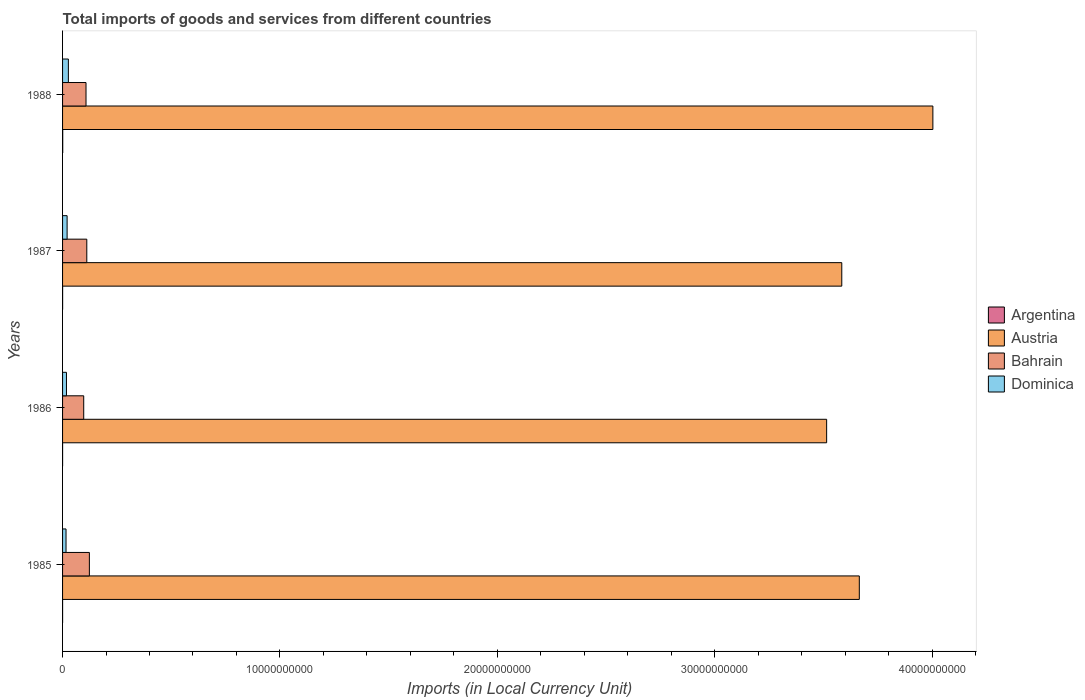How many different coloured bars are there?
Provide a short and direct response. 4. How many groups of bars are there?
Your response must be concise. 4. What is the Amount of goods and services imports in Dominica in 1985?
Ensure brevity in your answer.  1.60e+08. Across all years, what is the maximum Amount of goods and services imports in Dominica?
Offer a very short reply. 2.67e+08. Across all years, what is the minimum Amount of goods and services imports in Bahrain?
Your answer should be compact. 9.73e+08. In which year was the Amount of goods and services imports in Dominica maximum?
Give a very brief answer. 1988. What is the total Amount of goods and services imports in Bahrain in the graph?
Your response must be concise. 4.40e+09. What is the difference between the Amount of goods and services imports in Bahrain in 1986 and that in 1987?
Offer a terse response. -1.41e+08. What is the difference between the Amount of goods and services imports in Austria in 1988 and the Amount of goods and services imports in Argentina in 1985?
Make the answer very short. 4.00e+1. What is the average Amount of goods and services imports in Argentina per year?
Your answer should be very brief. 2.41e+06. In the year 1988, what is the difference between the Amount of goods and services imports in Argentina and Amount of goods and services imports in Austria?
Your response must be concise. -4.00e+1. In how many years, is the Amount of goods and services imports in Austria greater than 10000000000 LCU?
Your response must be concise. 4. What is the ratio of the Amount of goods and services imports in Argentina in 1986 to that in 1987?
Provide a short and direct response. 0.36. What is the difference between the highest and the second highest Amount of goods and services imports in Austria?
Make the answer very short. 3.38e+09. What is the difference between the highest and the lowest Amount of goods and services imports in Austria?
Your answer should be compact. 4.89e+09. In how many years, is the Amount of goods and services imports in Dominica greater than the average Amount of goods and services imports in Dominica taken over all years?
Make the answer very short. 2. Is it the case that in every year, the sum of the Amount of goods and services imports in Bahrain and Amount of goods and services imports in Argentina is greater than the sum of Amount of goods and services imports in Dominica and Amount of goods and services imports in Austria?
Give a very brief answer. No. What does the 1st bar from the top in 1985 represents?
Provide a short and direct response. Dominica. What does the 4th bar from the bottom in 1987 represents?
Make the answer very short. Dominica. What is the difference between two consecutive major ticks on the X-axis?
Provide a short and direct response. 1.00e+1. Are the values on the major ticks of X-axis written in scientific E-notation?
Give a very brief answer. No. Does the graph contain any zero values?
Your answer should be very brief. No. Does the graph contain grids?
Give a very brief answer. No. Where does the legend appear in the graph?
Your response must be concise. Center right. How many legend labels are there?
Your answer should be very brief. 4. What is the title of the graph?
Your answer should be very brief. Total imports of goods and services from different countries. What is the label or title of the X-axis?
Make the answer very short. Imports (in Local Currency Unit). What is the label or title of the Y-axis?
Your answer should be very brief. Years. What is the Imports (in Local Currency Unit) in Argentina in 1985?
Offer a very short reply. 3.33e+05. What is the Imports (in Local Currency Unit) in Austria in 1985?
Keep it short and to the point. 3.67e+1. What is the Imports (in Local Currency Unit) in Bahrain in 1985?
Provide a short and direct response. 1.23e+09. What is the Imports (in Local Currency Unit) of Dominica in 1985?
Your answer should be compact. 1.60e+08. What is the Imports (in Local Currency Unit) of Argentina in 1986?
Your response must be concise. 6.31e+05. What is the Imports (in Local Currency Unit) in Austria in 1986?
Give a very brief answer. 3.52e+1. What is the Imports (in Local Currency Unit) in Bahrain in 1986?
Your response must be concise. 9.73e+08. What is the Imports (in Local Currency Unit) of Dominica in 1986?
Provide a short and direct response. 1.79e+08. What is the Imports (in Local Currency Unit) of Argentina in 1987?
Provide a succinct answer. 1.77e+06. What is the Imports (in Local Currency Unit) in Austria in 1987?
Make the answer very short. 3.58e+1. What is the Imports (in Local Currency Unit) in Bahrain in 1987?
Your answer should be very brief. 1.11e+09. What is the Imports (in Local Currency Unit) in Dominica in 1987?
Your response must be concise. 2.09e+08. What is the Imports (in Local Currency Unit) in Argentina in 1988?
Provide a short and direct response. 6.90e+06. What is the Imports (in Local Currency Unit) in Austria in 1988?
Provide a succinct answer. 4.00e+1. What is the Imports (in Local Currency Unit) in Bahrain in 1988?
Provide a succinct answer. 1.08e+09. What is the Imports (in Local Currency Unit) of Dominica in 1988?
Your answer should be very brief. 2.67e+08. Across all years, what is the maximum Imports (in Local Currency Unit) of Argentina?
Your answer should be compact. 6.90e+06. Across all years, what is the maximum Imports (in Local Currency Unit) of Austria?
Your response must be concise. 4.00e+1. Across all years, what is the maximum Imports (in Local Currency Unit) of Bahrain?
Your answer should be very brief. 1.23e+09. Across all years, what is the maximum Imports (in Local Currency Unit) in Dominica?
Give a very brief answer. 2.67e+08. Across all years, what is the minimum Imports (in Local Currency Unit) of Argentina?
Make the answer very short. 3.33e+05. Across all years, what is the minimum Imports (in Local Currency Unit) in Austria?
Your answer should be compact. 3.52e+1. Across all years, what is the minimum Imports (in Local Currency Unit) of Bahrain?
Ensure brevity in your answer.  9.73e+08. Across all years, what is the minimum Imports (in Local Currency Unit) of Dominica?
Ensure brevity in your answer.  1.60e+08. What is the total Imports (in Local Currency Unit) in Argentina in the graph?
Keep it short and to the point. 9.63e+06. What is the total Imports (in Local Currency Unit) in Austria in the graph?
Your answer should be very brief. 1.48e+11. What is the total Imports (in Local Currency Unit) of Bahrain in the graph?
Provide a short and direct response. 4.40e+09. What is the total Imports (in Local Currency Unit) of Dominica in the graph?
Make the answer very short. 8.15e+08. What is the difference between the Imports (in Local Currency Unit) of Argentina in 1985 and that in 1986?
Give a very brief answer. -2.99e+05. What is the difference between the Imports (in Local Currency Unit) of Austria in 1985 and that in 1986?
Provide a short and direct response. 1.50e+09. What is the difference between the Imports (in Local Currency Unit) of Bahrain in 1985 and that in 1986?
Your response must be concise. 2.60e+08. What is the difference between the Imports (in Local Currency Unit) of Dominica in 1985 and that in 1986?
Your answer should be compact. -1.96e+07. What is the difference between the Imports (in Local Currency Unit) in Argentina in 1985 and that in 1987?
Offer a very short reply. -1.43e+06. What is the difference between the Imports (in Local Currency Unit) of Austria in 1985 and that in 1987?
Provide a short and direct response. 8.06e+08. What is the difference between the Imports (in Local Currency Unit) of Bahrain in 1985 and that in 1987?
Give a very brief answer. 1.19e+08. What is the difference between the Imports (in Local Currency Unit) in Dominica in 1985 and that in 1987?
Give a very brief answer. -4.97e+07. What is the difference between the Imports (in Local Currency Unit) of Argentina in 1985 and that in 1988?
Provide a succinct answer. -6.57e+06. What is the difference between the Imports (in Local Currency Unit) in Austria in 1985 and that in 1988?
Provide a short and direct response. -3.38e+09. What is the difference between the Imports (in Local Currency Unit) of Bahrain in 1985 and that in 1988?
Offer a very short reply. 1.55e+08. What is the difference between the Imports (in Local Currency Unit) in Dominica in 1985 and that in 1988?
Provide a succinct answer. -1.07e+08. What is the difference between the Imports (in Local Currency Unit) of Argentina in 1986 and that in 1987?
Provide a succinct answer. -1.14e+06. What is the difference between the Imports (in Local Currency Unit) of Austria in 1986 and that in 1987?
Your answer should be compact. -6.96e+08. What is the difference between the Imports (in Local Currency Unit) in Bahrain in 1986 and that in 1987?
Offer a very short reply. -1.41e+08. What is the difference between the Imports (in Local Currency Unit) of Dominica in 1986 and that in 1987?
Offer a very short reply. -3.01e+07. What is the difference between the Imports (in Local Currency Unit) in Argentina in 1986 and that in 1988?
Your answer should be compact. -6.27e+06. What is the difference between the Imports (in Local Currency Unit) of Austria in 1986 and that in 1988?
Your answer should be very brief. -4.89e+09. What is the difference between the Imports (in Local Currency Unit) in Bahrain in 1986 and that in 1988?
Your answer should be very brief. -1.05e+08. What is the difference between the Imports (in Local Currency Unit) in Dominica in 1986 and that in 1988?
Offer a terse response. -8.78e+07. What is the difference between the Imports (in Local Currency Unit) of Argentina in 1987 and that in 1988?
Keep it short and to the point. -5.13e+06. What is the difference between the Imports (in Local Currency Unit) in Austria in 1987 and that in 1988?
Keep it short and to the point. -4.19e+09. What is the difference between the Imports (in Local Currency Unit) in Bahrain in 1987 and that in 1988?
Provide a short and direct response. 3.59e+07. What is the difference between the Imports (in Local Currency Unit) in Dominica in 1987 and that in 1988?
Your response must be concise. -5.78e+07. What is the difference between the Imports (in Local Currency Unit) in Argentina in 1985 and the Imports (in Local Currency Unit) in Austria in 1986?
Your response must be concise. -3.52e+1. What is the difference between the Imports (in Local Currency Unit) in Argentina in 1985 and the Imports (in Local Currency Unit) in Bahrain in 1986?
Your answer should be very brief. -9.73e+08. What is the difference between the Imports (in Local Currency Unit) of Argentina in 1985 and the Imports (in Local Currency Unit) of Dominica in 1986?
Provide a succinct answer. -1.79e+08. What is the difference between the Imports (in Local Currency Unit) of Austria in 1985 and the Imports (in Local Currency Unit) of Bahrain in 1986?
Make the answer very short. 3.57e+1. What is the difference between the Imports (in Local Currency Unit) in Austria in 1985 and the Imports (in Local Currency Unit) in Dominica in 1986?
Provide a short and direct response. 3.65e+1. What is the difference between the Imports (in Local Currency Unit) in Bahrain in 1985 and the Imports (in Local Currency Unit) in Dominica in 1986?
Your answer should be very brief. 1.05e+09. What is the difference between the Imports (in Local Currency Unit) in Argentina in 1985 and the Imports (in Local Currency Unit) in Austria in 1987?
Offer a terse response. -3.58e+1. What is the difference between the Imports (in Local Currency Unit) of Argentina in 1985 and the Imports (in Local Currency Unit) of Bahrain in 1987?
Provide a short and direct response. -1.11e+09. What is the difference between the Imports (in Local Currency Unit) of Argentina in 1985 and the Imports (in Local Currency Unit) of Dominica in 1987?
Offer a very short reply. -2.09e+08. What is the difference between the Imports (in Local Currency Unit) in Austria in 1985 and the Imports (in Local Currency Unit) in Bahrain in 1987?
Your answer should be compact. 3.55e+1. What is the difference between the Imports (in Local Currency Unit) in Austria in 1985 and the Imports (in Local Currency Unit) in Dominica in 1987?
Keep it short and to the point. 3.64e+1. What is the difference between the Imports (in Local Currency Unit) in Bahrain in 1985 and the Imports (in Local Currency Unit) in Dominica in 1987?
Give a very brief answer. 1.02e+09. What is the difference between the Imports (in Local Currency Unit) of Argentina in 1985 and the Imports (in Local Currency Unit) of Austria in 1988?
Give a very brief answer. -4.00e+1. What is the difference between the Imports (in Local Currency Unit) of Argentina in 1985 and the Imports (in Local Currency Unit) of Bahrain in 1988?
Your answer should be very brief. -1.08e+09. What is the difference between the Imports (in Local Currency Unit) of Argentina in 1985 and the Imports (in Local Currency Unit) of Dominica in 1988?
Keep it short and to the point. -2.67e+08. What is the difference between the Imports (in Local Currency Unit) in Austria in 1985 and the Imports (in Local Currency Unit) in Bahrain in 1988?
Your answer should be very brief. 3.56e+1. What is the difference between the Imports (in Local Currency Unit) in Austria in 1985 and the Imports (in Local Currency Unit) in Dominica in 1988?
Offer a very short reply. 3.64e+1. What is the difference between the Imports (in Local Currency Unit) in Bahrain in 1985 and the Imports (in Local Currency Unit) in Dominica in 1988?
Your answer should be compact. 9.67e+08. What is the difference between the Imports (in Local Currency Unit) in Argentina in 1986 and the Imports (in Local Currency Unit) in Austria in 1987?
Offer a terse response. -3.58e+1. What is the difference between the Imports (in Local Currency Unit) in Argentina in 1986 and the Imports (in Local Currency Unit) in Bahrain in 1987?
Offer a very short reply. -1.11e+09. What is the difference between the Imports (in Local Currency Unit) of Argentina in 1986 and the Imports (in Local Currency Unit) of Dominica in 1987?
Ensure brevity in your answer.  -2.09e+08. What is the difference between the Imports (in Local Currency Unit) of Austria in 1986 and the Imports (in Local Currency Unit) of Bahrain in 1987?
Provide a succinct answer. 3.40e+1. What is the difference between the Imports (in Local Currency Unit) of Austria in 1986 and the Imports (in Local Currency Unit) of Dominica in 1987?
Your response must be concise. 3.49e+1. What is the difference between the Imports (in Local Currency Unit) in Bahrain in 1986 and the Imports (in Local Currency Unit) in Dominica in 1987?
Give a very brief answer. 7.64e+08. What is the difference between the Imports (in Local Currency Unit) of Argentina in 1986 and the Imports (in Local Currency Unit) of Austria in 1988?
Keep it short and to the point. -4.00e+1. What is the difference between the Imports (in Local Currency Unit) of Argentina in 1986 and the Imports (in Local Currency Unit) of Bahrain in 1988?
Offer a very short reply. -1.08e+09. What is the difference between the Imports (in Local Currency Unit) of Argentina in 1986 and the Imports (in Local Currency Unit) of Dominica in 1988?
Offer a terse response. -2.66e+08. What is the difference between the Imports (in Local Currency Unit) of Austria in 1986 and the Imports (in Local Currency Unit) of Bahrain in 1988?
Offer a very short reply. 3.41e+1. What is the difference between the Imports (in Local Currency Unit) in Austria in 1986 and the Imports (in Local Currency Unit) in Dominica in 1988?
Your answer should be very brief. 3.49e+1. What is the difference between the Imports (in Local Currency Unit) in Bahrain in 1986 and the Imports (in Local Currency Unit) in Dominica in 1988?
Your answer should be very brief. 7.06e+08. What is the difference between the Imports (in Local Currency Unit) in Argentina in 1987 and the Imports (in Local Currency Unit) in Austria in 1988?
Ensure brevity in your answer.  -4.00e+1. What is the difference between the Imports (in Local Currency Unit) in Argentina in 1987 and the Imports (in Local Currency Unit) in Bahrain in 1988?
Offer a terse response. -1.08e+09. What is the difference between the Imports (in Local Currency Unit) in Argentina in 1987 and the Imports (in Local Currency Unit) in Dominica in 1988?
Your answer should be very brief. -2.65e+08. What is the difference between the Imports (in Local Currency Unit) of Austria in 1987 and the Imports (in Local Currency Unit) of Bahrain in 1988?
Your response must be concise. 3.48e+1. What is the difference between the Imports (in Local Currency Unit) of Austria in 1987 and the Imports (in Local Currency Unit) of Dominica in 1988?
Ensure brevity in your answer.  3.56e+1. What is the difference between the Imports (in Local Currency Unit) in Bahrain in 1987 and the Imports (in Local Currency Unit) in Dominica in 1988?
Make the answer very short. 8.48e+08. What is the average Imports (in Local Currency Unit) of Argentina per year?
Your response must be concise. 2.41e+06. What is the average Imports (in Local Currency Unit) in Austria per year?
Your response must be concise. 3.69e+1. What is the average Imports (in Local Currency Unit) of Bahrain per year?
Make the answer very short. 1.10e+09. What is the average Imports (in Local Currency Unit) in Dominica per year?
Make the answer very short. 2.04e+08. In the year 1985, what is the difference between the Imports (in Local Currency Unit) of Argentina and Imports (in Local Currency Unit) of Austria?
Your answer should be very brief. -3.67e+1. In the year 1985, what is the difference between the Imports (in Local Currency Unit) in Argentina and Imports (in Local Currency Unit) in Bahrain?
Your answer should be compact. -1.23e+09. In the year 1985, what is the difference between the Imports (in Local Currency Unit) of Argentina and Imports (in Local Currency Unit) of Dominica?
Your answer should be very brief. -1.59e+08. In the year 1985, what is the difference between the Imports (in Local Currency Unit) of Austria and Imports (in Local Currency Unit) of Bahrain?
Your response must be concise. 3.54e+1. In the year 1985, what is the difference between the Imports (in Local Currency Unit) in Austria and Imports (in Local Currency Unit) in Dominica?
Provide a short and direct response. 3.65e+1. In the year 1985, what is the difference between the Imports (in Local Currency Unit) in Bahrain and Imports (in Local Currency Unit) in Dominica?
Ensure brevity in your answer.  1.07e+09. In the year 1986, what is the difference between the Imports (in Local Currency Unit) of Argentina and Imports (in Local Currency Unit) of Austria?
Offer a terse response. -3.52e+1. In the year 1986, what is the difference between the Imports (in Local Currency Unit) in Argentina and Imports (in Local Currency Unit) in Bahrain?
Offer a very short reply. -9.73e+08. In the year 1986, what is the difference between the Imports (in Local Currency Unit) of Argentina and Imports (in Local Currency Unit) of Dominica?
Keep it short and to the point. -1.79e+08. In the year 1986, what is the difference between the Imports (in Local Currency Unit) in Austria and Imports (in Local Currency Unit) in Bahrain?
Your answer should be compact. 3.42e+1. In the year 1986, what is the difference between the Imports (in Local Currency Unit) of Austria and Imports (in Local Currency Unit) of Dominica?
Offer a very short reply. 3.50e+1. In the year 1986, what is the difference between the Imports (in Local Currency Unit) of Bahrain and Imports (in Local Currency Unit) of Dominica?
Offer a very short reply. 7.94e+08. In the year 1987, what is the difference between the Imports (in Local Currency Unit) in Argentina and Imports (in Local Currency Unit) in Austria?
Your answer should be very brief. -3.58e+1. In the year 1987, what is the difference between the Imports (in Local Currency Unit) of Argentina and Imports (in Local Currency Unit) of Bahrain?
Provide a succinct answer. -1.11e+09. In the year 1987, what is the difference between the Imports (in Local Currency Unit) of Argentina and Imports (in Local Currency Unit) of Dominica?
Give a very brief answer. -2.07e+08. In the year 1987, what is the difference between the Imports (in Local Currency Unit) in Austria and Imports (in Local Currency Unit) in Bahrain?
Offer a terse response. 3.47e+1. In the year 1987, what is the difference between the Imports (in Local Currency Unit) in Austria and Imports (in Local Currency Unit) in Dominica?
Offer a very short reply. 3.56e+1. In the year 1987, what is the difference between the Imports (in Local Currency Unit) in Bahrain and Imports (in Local Currency Unit) in Dominica?
Make the answer very short. 9.05e+08. In the year 1988, what is the difference between the Imports (in Local Currency Unit) of Argentina and Imports (in Local Currency Unit) of Austria?
Keep it short and to the point. -4.00e+1. In the year 1988, what is the difference between the Imports (in Local Currency Unit) of Argentina and Imports (in Local Currency Unit) of Bahrain?
Offer a very short reply. -1.07e+09. In the year 1988, what is the difference between the Imports (in Local Currency Unit) of Argentina and Imports (in Local Currency Unit) of Dominica?
Your response must be concise. -2.60e+08. In the year 1988, what is the difference between the Imports (in Local Currency Unit) of Austria and Imports (in Local Currency Unit) of Bahrain?
Provide a short and direct response. 3.90e+1. In the year 1988, what is the difference between the Imports (in Local Currency Unit) in Austria and Imports (in Local Currency Unit) in Dominica?
Provide a short and direct response. 3.98e+1. In the year 1988, what is the difference between the Imports (in Local Currency Unit) of Bahrain and Imports (in Local Currency Unit) of Dominica?
Your answer should be compact. 8.12e+08. What is the ratio of the Imports (in Local Currency Unit) of Argentina in 1985 to that in 1986?
Offer a very short reply. 0.53. What is the ratio of the Imports (in Local Currency Unit) in Austria in 1985 to that in 1986?
Keep it short and to the point. 1.04. What is the ratio of the Imports (in Local Currency Unit) of Bahrain in 1985 to that in 1986?
Your answer should be compact. 1.27. What is the ratio of the Imports (in Local Currency Unit) in Dominica in 1985 to that in 1986?
Make the answer very short. 0.89. What is the ratio of the Imports (in Local Currency Unit) of Argentina in 1985 to that in 1987?
Give a very brief answer. 0.19. What is the ratio of the Imports (in Local Currency Unit) of Austria in 1985 to that in 1987?
Make the answer very short. 1.02. What is the ratio of the Imports (in Local Currency Unit) in Bahrain in 1985 to that in 1987?
Offer a terse response. 1.11. What is the ratio of the Imports (in Local Currency Unit) of Dominica in 1985 to that in 1987?
Your answer should be very brief. 0.76. What is the ratio of the Imports (in Local Currency Unit) of Argentina in 1985 to that in 1988?
Your answer should be very brief. 0.05. What is the ratio of the Imports (in Local Currency Unit) of Austria in 1985 to that in 1988?
Your answer should be compact. 0.92. What is the ratio of the Imports (in Local Currency Unit) of Bahrain in 1985 to that in 1988?
Your answer should be very brief. 1.14. What is the ratio of the Imports (in Local Currency Unit) of Dominica in 1985 to that in 1988?
Your answer should be very brief. 0.6. What is the ratio of the Imports (in Local Currency Unit) of Argentina in 1986 to that in 1987?
Your answer should be compact. 0.36. What is the ratio of the Imports (in Local Currency Unit) in Austria in 1986 to that in 1987?
Offer a very short reply. 0.98. What is the ratio of the Imports (in Local Currency Unit) of Bahrain in 1986 to that in 1987?
Your answer should be very brief. 0.87. What is the ratio of the Imports (in Local Currency Unit) of Dominica in 1986 to that in 1987?
Give a very brief answer. 0.86. What is the ratio of the Imports (in Local Currency Unit) of Argentina in 1986 to that in 1988?
Give a very brief answer. 0.09. What is the ratio of the Imports (in Local Currency Unit) of Austria in 1986 to that in 1988?
Your answer should be compact. 0.88. What is the ratio of the Imports (in Local Currency Unit) of Bahrain in 1986 to that in 1988?
Provide a succinct answer. 0.9. What is the ratio of the Imports (in Local Currency Unit) of Dominica in 1986 to that in 1988?
Offer a terse response. 0.67. What is the ratio of the Imports (in Local Currency Unit) of Argentina in 1987 to that in 1988?
Your answer should be compact. 0.26. What is the ratio of the Imports (in Local Currency Unit) in Austria in 1987 to that in 1988?
Provide a succinct answer. 0.9. What is the ratio of the Imports (in Local Currency Unit) in Dominica in 1987 to that in 1988?
Make the answer very short. 0.78. What is the difference between the highest and the second highest Imports (in Local Currency Unit) in Argentina?
Your answer should be very brief. 5.13e+06. What is the difference between the highest and the second highest Imports (in Local Currency Unit) of Austria?
Your answer should be compact. 3.38e+09. What is the difference between the highest and the second highest Imports (in Local Currency Unit) of Bahrain?
Offer a very short reply. 1.19e+08. What is the difference between the highest and the second highest Imports (in Local Currency Unit) in Dominica?
Keep it short and to the point. 5.78e+07. What is the difference between the highest and the lowest Imports (in Local Currency Unit) in Argentina?
Keep it short and to the point. 6.57e+06. What is the difference between the highest and the lowest Imports (in Local Currency Unit) in Austria?
Ensure brevity in your answer.  4.89e+09. What is the difference between the highest and the lowest Imports (in Local Currency Unit) in Bahrain?
Ensure brevity in your answer.  2.60e+08. What is the difference between the highest and the lowest Imports (in Local Currency Unit) of Dominica?
Ensure brevity in your answer.  1.07e+08. 